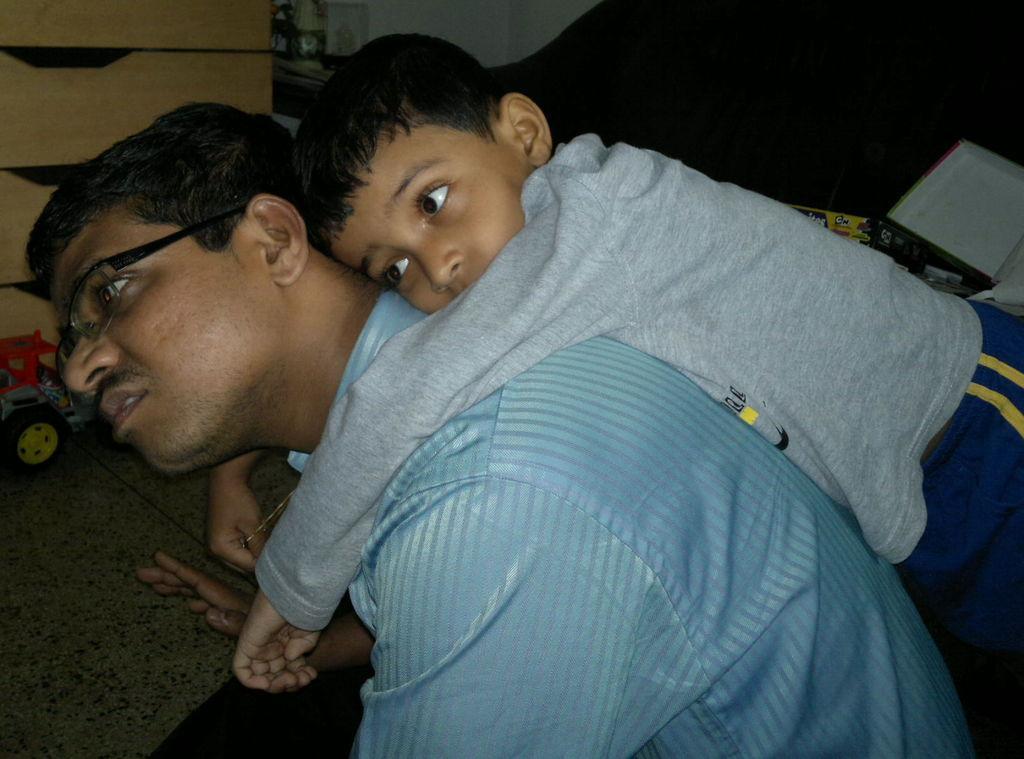How would you summarize this image in a sentence or two? In this picture, we see the man in the blue shirt is sitting on the sofa. Behind him, we see a boy in grey T-shirt is lying on his back. On the right side, we see game boxes. On the left side, we see a toy vehicle. Beside that, we see a cupboard and a white wall. Beside that, it is black in color. This picture might be clicked inside the room. 